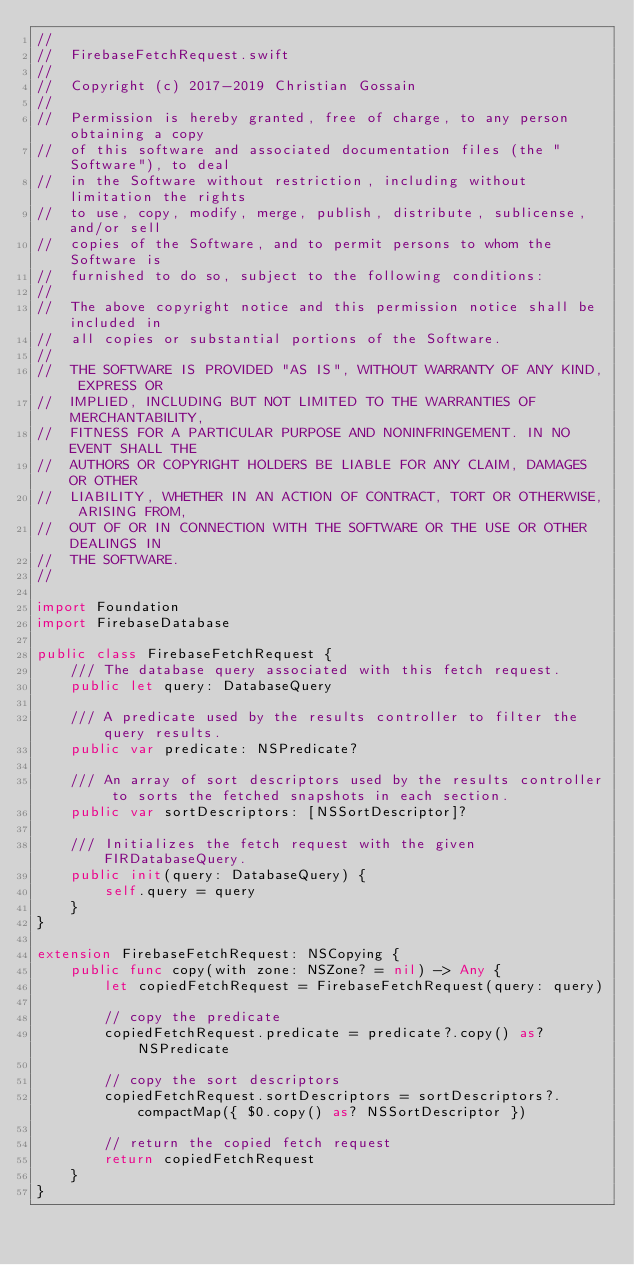<code> <loc_0><loc_0><loc_500><loc_500><_Swift_>//
//  FirebaseFetchRequest.swift
//
//  Copyright (c) 2017-2019 Christian Gossain
//
//  Permission is hereby granted, free of charge, to any person obtaining a copy
//  of this software and associated documentation files (the "Software"), to deal
//  in the Software without restriction, including without limitation the rights
//  to use, copy, modify, merge, publish, distribute, sublicense, and/or sell
//  copies of the Software, and to permit persons to whom the Software is
//  furnished to do so, subject to the following conditions:
//
//  The above copyright notice and this permission notice shall be included in
//  all copies or substantial portions of the Software.
//
//  THE SOFTWARE IS PROVIDED "AS IS", WITHOUT WARRANTY OF ANY KIND, EXPRESS OR
//  IMPLIED, INCLUDING BUT NOT LIMITED TO THE WARRANTIES OF MERCHANTABILITY,
//  FITNESS FOR A PARTICULAR PURPOSE AND NONINFRINGEMENT. IN NO EVENT SHALL THE
//  AUTHORS OR COPYRIGHT HOLDERS BE LIABLE FOR ANY CLAIM, DAMAGES OR OTHER
//  LIABILITY, WHETHER IN AN ACTION OF CONTRACT, TORT OR OTHERWISE, ARISING FROM,
//  OUT OF OR IN CONNECTION WITH THE SOFTWARE OR THE USE OR OTHER DEALINGS IN
//  THE SOFTWARE.
//

import Foundation
import FirebaseDatabase

public class FirebaseFetchRequest {
    /// The database query associated with this fetch request.
    public let query: DatabaseQuery
    
    /// A predicate used by the results controller to filter the query results.
    public var predicate: NSPredicate?
    
    /// An array of sort descriptors used by the results controller to sorts the fetched snapshots in each section.
    public var sortDescriptors: [NSSortDescriptor]?
    
    /// Initializes the fetch request with the given FIRDatabaseQuery.
    public init(query: DatabaseQuery) {
        self.query = query
    }
}

extension FirebaseFetchRequest: NSCopying {
    public func copy(with zone: NSZone? = nil) -> Any {
        let copiedFetchRequest = FirebaseFetchRequest(query: query)
        
        // copy the predicate
        copiedFetchRequest.predicate = predicate?.copy() as? NSPredicate
        
        // copy the sort descriptors
        copiedFetchRequest.sortDescriptors = sortDescriptors?.compactMap({ $0.copy() as? NSSortDescriptor })
        
        // return the copied fetch request
        return copiedFetchRequest
    }
}
</code> 